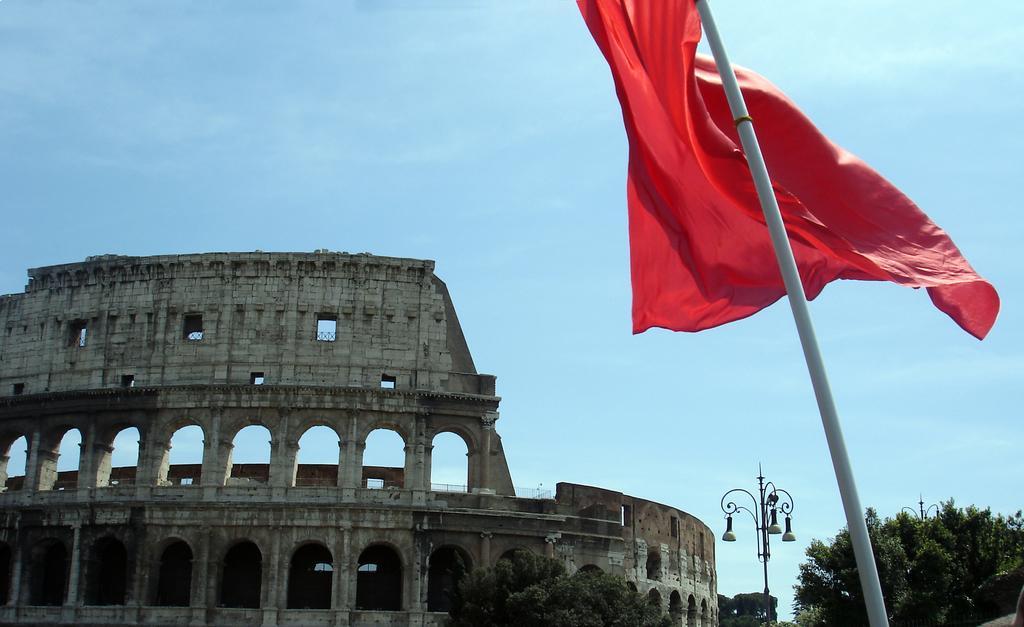Could you give a brief overview of what you see in this image? In this image on the right side there is one fort and there are some trees, at the bottom on the right side there is one pole and flag and at the bottom there is one pole and some lights. On the top of the image there is sky. 